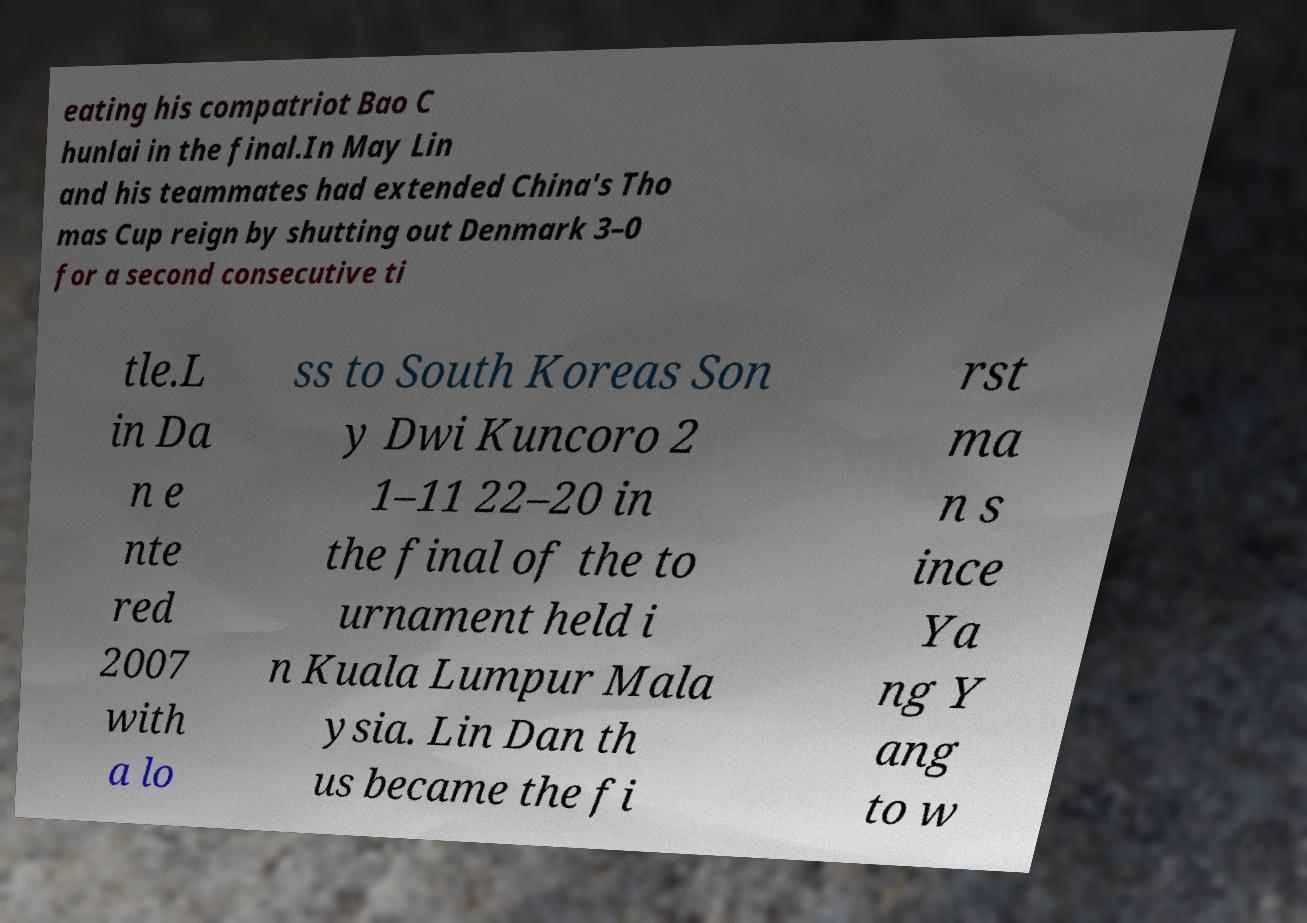Can you read and provide the text displayed in the image?This photo seems to have some interesting text. Can you extract and type it out for me? eating his compatriot Bao C hunlai in the final.In May Lin and his teammates had extended China's Tho mas Cup reign by shutting out Denmark 3–0 for a second consecutive ti tle.L in Da n e nte red 2007 with a lo ss to South Koreas Son y Dwi Kuncoro 2 1–11 22–20 in the final of the to urnament held i n Kuala Lumpur Mala ysia. Lin Dan th us became the fi rst ma n s ince Ya ng Y ang to w 